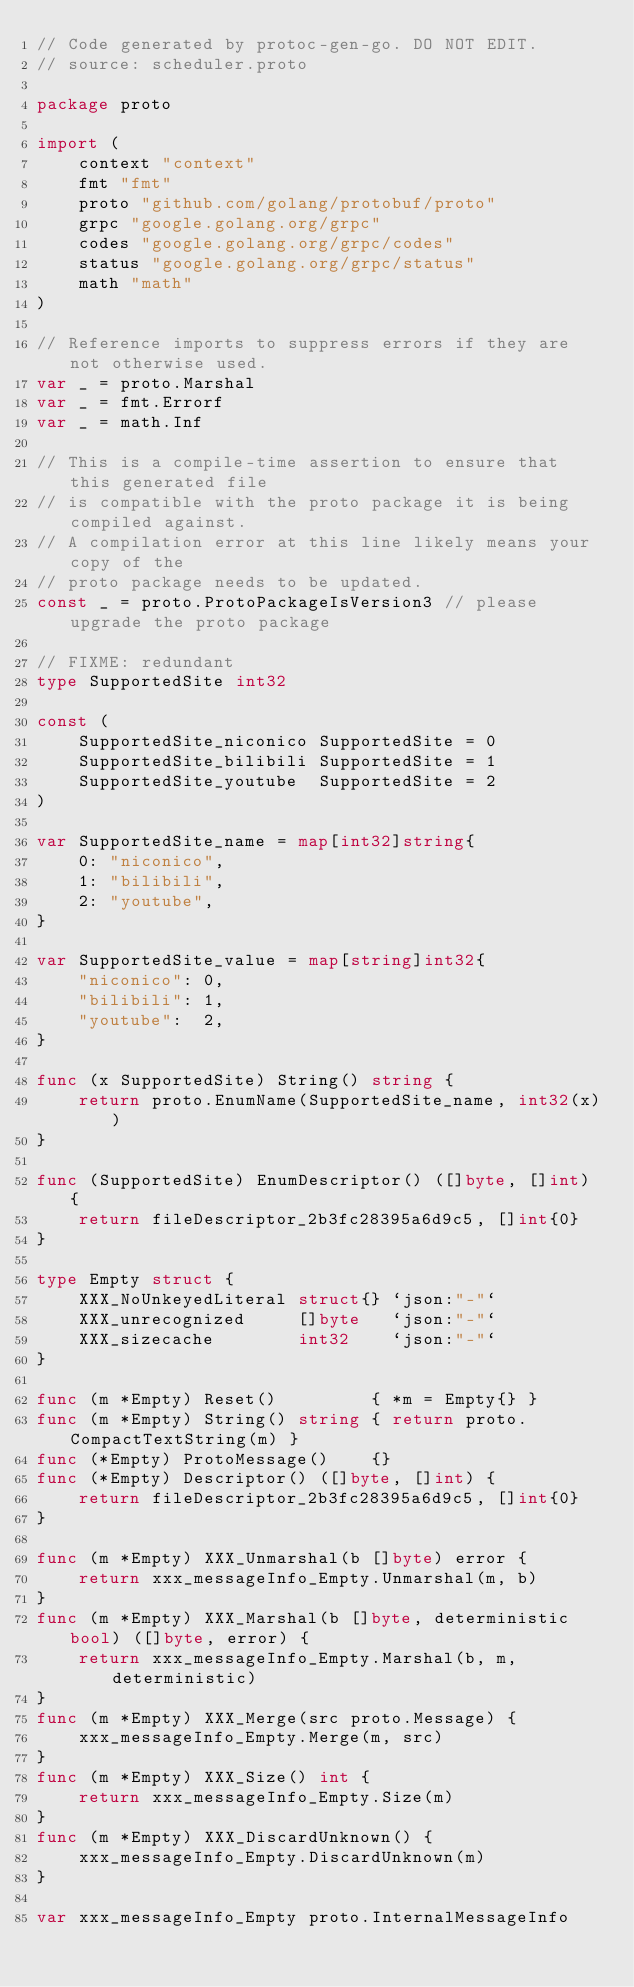Convert code to text. <code><loc_0><loc_0><loc_500><loc_500><_Go_>// Code generated by protoc-gen-go. DO NOT EDIT.
// source: scheduler.proto

package proto

import (
	context "context"
	fmt "fmt"
	proto "github.com/golang/protobuf/proto"
	grpc "google.golang.org/grpc"
	codes "google.golang.org/grpc/codes"
	status "google.golang.org/grpc/status"
	math "math"
)

// Reference imports to suppress errors if they are not otherwise used.
var _ = proto.Marshal
var _ = fmt.Errorf
var _ = math.Inf

// This is a compile-time assertion to ensure that this generated file
// is compatible with the proto package it is being compiled against.
// A compilation error at this line likely means your copy of the
// proto package needs to be updated.
const _ = proto.ProtoPackageIsVersion3 // please upgrade the proto package

// FIXME: redundant
type SupportedSite int32

const (
	SupportedSite_niconico SupportedSite = 0
	SupportedSite_bilibili SupportedSite = 1
	SupportedSite_youtube  SupportedSite = 2
)

var SupportedSite_name = map[int32]string{
	0: "niconico",
	1: "bilibili",
	2: "youtube",
}

var SupportedSite_value = map[string]int32{
	"niconico": 0,
	"bilibili": 1,
	"youtube":  2,
}

func (x SupportedSite) String() string {
	return proto.EnumName(SupportedSite_name, int32(x))
}

func (SupportedSite) EnumDescriptor() ([]byte, []int) {
	return fileDescriptor_2b3fc28395a6d9c5, []int{0}
}

type Empty struct {
	XXX_NoUnkeyedLiteral struct{} `json:"-"`
	XXX_unrecognized     []byte   `json:"-"`
	XXX_sizecache        int32    `json:"-"`
}

func (m *Empty) Reset()         { *m = Empty{} }
func (m *Empty) String() string { return proto.CompactTextString(m) }
func (*Empty) ProtoMessage()    {}
func (*Empty) Descriptor() ([]byte, []int) {
	return fileDescriptor_2b3fc28395a6d9c5, []int{0}
}

func (m *Empty) XXX_Unmarshal(b []byte) error {
	return xxx_messageInfo_Empty.Unmarshal(m, b)
}
func (m *Empty) XXX_Marshal(b []byte, deterministic bool) ([]byte, error) {
	return xxx_messageInfo_Empty.Marshal(b, m, deterministic)
}
func (m *Empty) XXX_Merge(src proto.Message) {
	xxx_messageInfo_Empty.Merge(m, src)
}
func (m *Empty) XXX_Size() int {
	return xxx_messageInfo_Empty.Size(m)
}
func (m *Empty) XXX_DiscardUnknown() {
	xxx_messageInfo_Empty.DiscardUnknown(m)
}

var xxx_messageInfo_Empty proto.InternalMessageInfo
</code> 